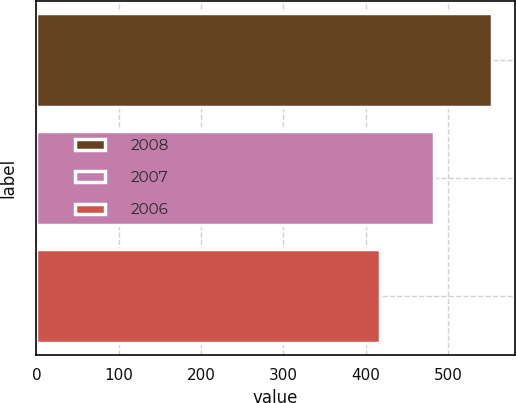<chart> <loc_0><loc_0><loc_500><loc_500><bar_chart><fcel>2008<fcel>2007<fcel>2006<nl><fcel>553.7<fcel>483<fcel>417<nl></chart> 